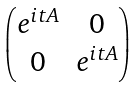Convert formula to latex. <formula><loc_0><loc_0><loc_500><loc_500>\begin{pmatrix} e ^ { i t A } & 0 \\ 0 & e ^ { i t A } \end{pmatrix}</formula> 